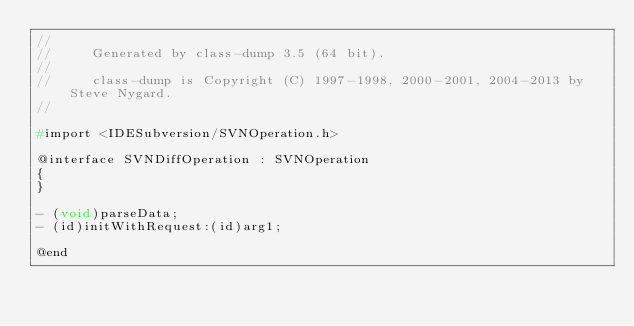<code> <loc_0><loc_0><loc_500><loc_500><_C_>//
//     Generated by class-dump 3.5 (64 bit).
//
//     class-dump is Copyright (C) 1997-1998, 2000-2001, 2004-2013 by Steve Nygard.
//

#import <IDESubversion/SVNOperation.h>

@interface SVNDiffOperation : SVNOperation
{
}

- (void)parseData;
- (id)initWithRequest:(id)arg1;

@end

</code> 